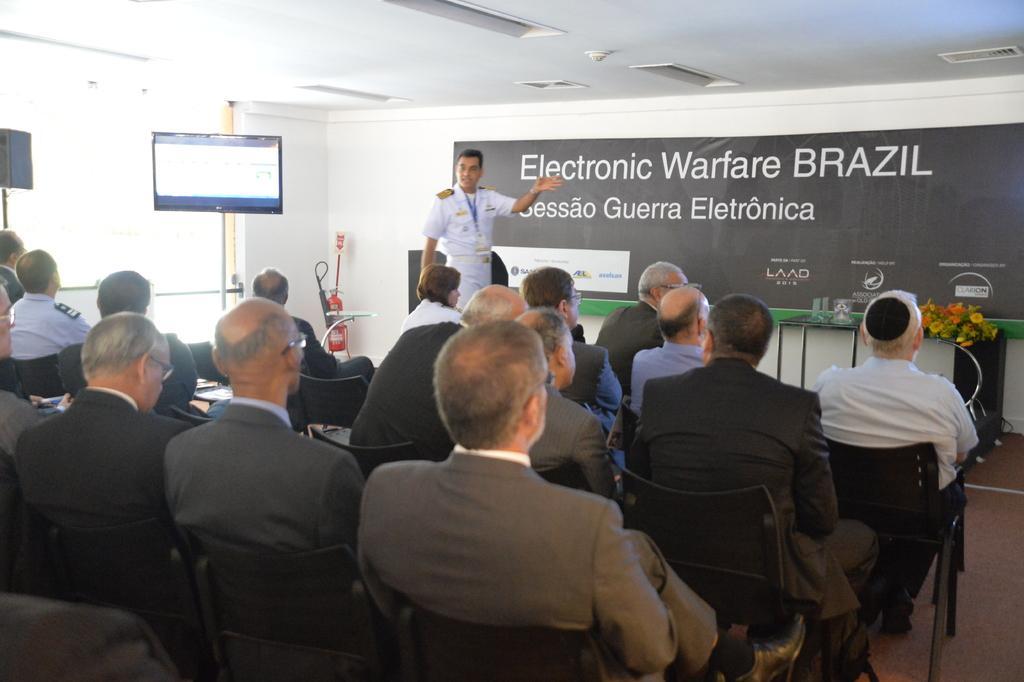Can you describe this image briefly? In this image, we can see persons wearing clothes and sitting on chairs. There is a person standing in front of the banner. There is a screen on the left side of the image. There are lights on the ceiling which is at the top of the image. There are flowers on the right side of the image. There is a table in front of the wall. 